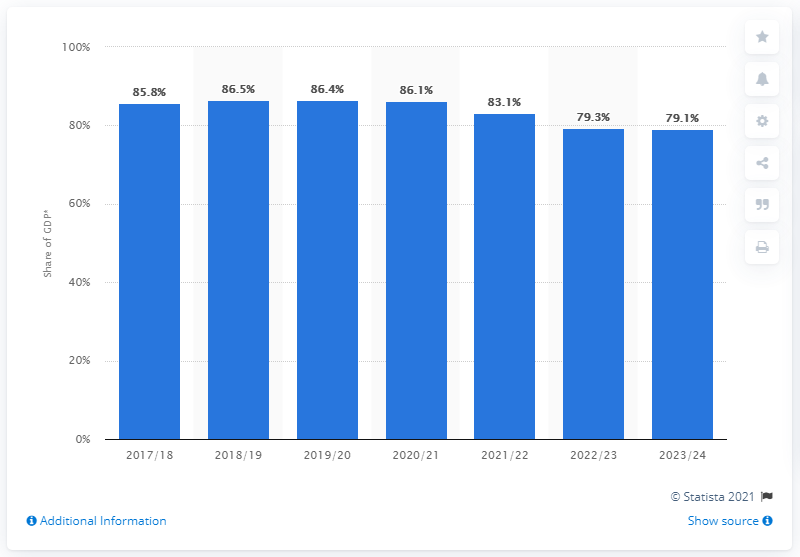Identify some key points in this picture. According to the forecast, the UK's public sector net debt is expected to end in the financial year 2023/24. The forecast for the United Kingdom's public sector net debt was made in 2017/2018. 